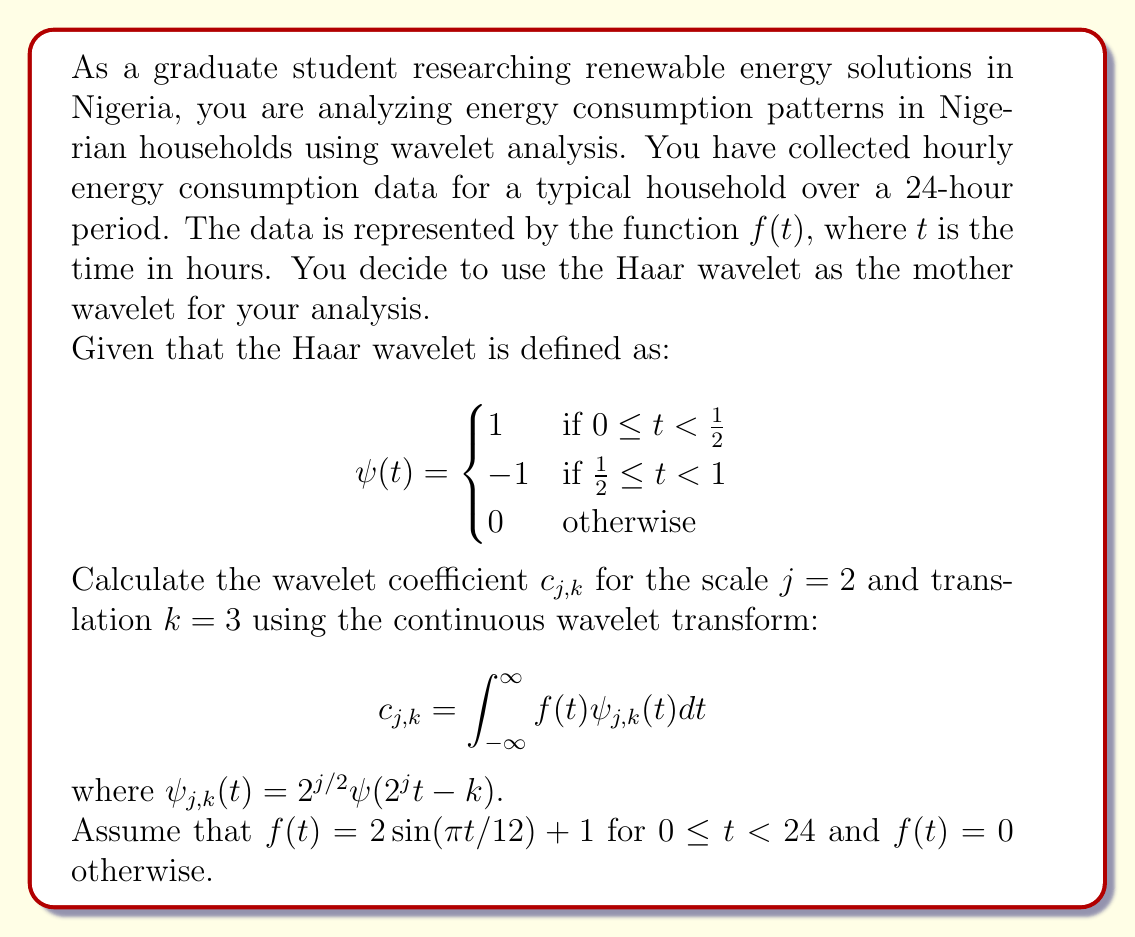Solve this math problem. To solve this problem, we need to follow these steps:

1) First, let's determine the support of $\psi_{2,3}(t)$:
   
   $2^j t - k = 2^2 t - 3 = 4t - 3$
   
   For the non-zero part of $\psi(t)$, we need:
   $0 \leq 4t - 3 < 1$
   $3 \leq 4t < 4$
   $\frac{3}{4} \leq t < 1$

2) Now, we can write out $\psi_{2,3}(t)$:

   $$\psi_{2,3}(t) = 2^{2/2} \psi(4t - 3) = 2 \begin{cases}
   1 & \text{if } \frac{3}{4} \leq t < \frac{7}{8} \\
   -1 & \text{if } \frac{7}{8} \leq t < 1 \\
   0 & \text{otherwise}
   \end{cases}$$

3) The wavelet coefficient is given by:

   $$c_{2,3} = \int_{-\infty}^{\infty} f(t) \psi_{2,3}(t) dt$$

   Due to the support of $\psi_{2,3}(t)$, we can rewrite this as:

   $$c_{2,3} = \int_{\frac{3}{4}}^{\frac{7}{8}} f(t) \cdot 2 dt - \int_{\frac{7}{8}}^{1} f(t) \cdot 2 dt$$

4) Substituting $f(t) = 2\sin(\pi t/12) + 1$:

   $$c_{2,3} = \int_{\frac{3}{4}}^{\frac{7}{8}} (2\sin(\pi t/12) + 1) \cdot 2 dt - \int_{\frac{7}{8}}^{1} (2\sin(\pi t/12) + 1) \cdot 2 dt$$

5) Evaluating these integrals:

   $$c_{2,3} = \left[-\frac{48}{\pi}\cos(\frac{\pi t}{12}) + 2t\right]_{\frac{3}{4}}^{\frac{7}{8}} - \left[-\frac{48}{\pi}\cos(\frac{\pi t}{12}) + 2t\right]_{\frac{7}{8}}^{1}$$

6) Calculating the difference:

   $$c_{2,3} = \left(-\frac{48}{\pi}\cos(\frac{7\pi}{96}) + \frac{7}{4}\right) - \left(-\frac{48}{\pi}\cos(\frac{3\pi}{48}) + \frac{3}{2}\right) - \left(-\frac{48}{\pi}\cos(\frac{\pi}{12}) + 2\right) + \left(-\frac{48}{\pi}\cos(\frac{7\pi}{96}) + \frac{7}{4}\right)$$

7) Simplifying:

   $$c_{2,3} = -\frac{48}{\pi}\left(\cos(\frac{\pi}{12}) - \cos(\frac{3\pi}{48})\right) - \frac{1}{4}$$
Answer: $$c_{2,3} = -\frac{48}{\pi}\left(\cos(\frac{\pi}{12}) - \cos(\frac{3\pi}{48})\right) - \frac{1}{4}$$ 